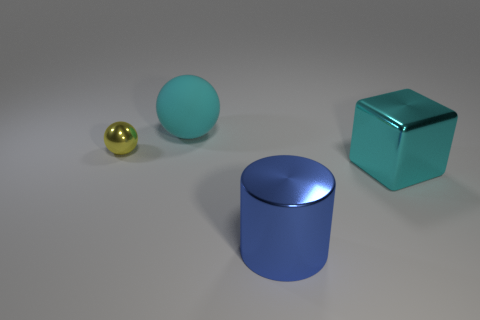Add 1 big red metal things. How many objects exist? 5 Subtract all blocks. How many objects are left? 3 Subtract 0 brown cubes. How many objects are left? 4 Subtract all purple metallic spheres. Subtract all cyan objects. How many objects are left? 2 Add 3 tiny yellow shiny spheres. How many tiny yellow shiny spheres are left? 4 Add 4 green metal blocks. How many green metal blocks exist? 4 